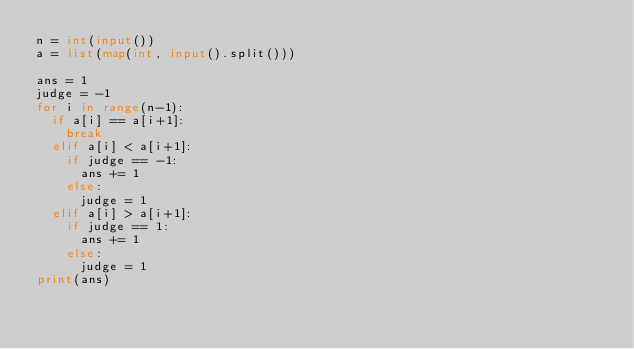Convert code to text. <code><loc_0><loc_0><loc_500><loc_500><_Python_>n = int(input())
a = list(map(int, input().split()))

ans = 1
judge = -1
for i in range(n-1):
  if a[i] == a[i+1]:
    break
  elif a[i] < a[i+1]:
    if judge == -1:
      ans += 1
    else:
      judge = 1
  elif a[i] > a[i+1]:
    if judge == 1:
      ans += 1
    else:
      judge = 1      
print(ans)</code> 